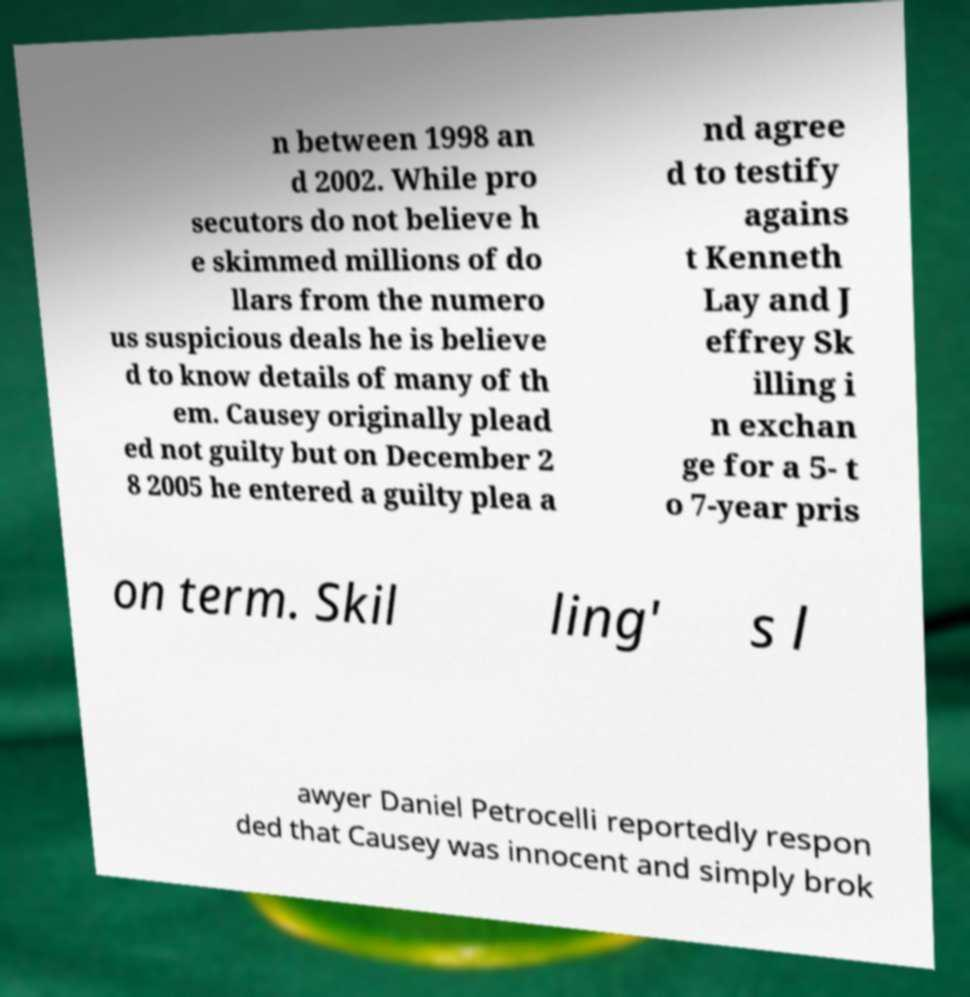For documentation purposes, I need the text within this image transcribed. Could you provide that? n between 1998 an d 2002. While pro secutors do not believe h e skimmed millions of do llars from the numero us suspicious deals he is believe d to know details of many of th em. Causey originally plead ed not guilty but on December 2 8 2005 he entered a guilty plea a nd agree d to testify agains t Kenneth Lay and J effrey Sk illing i n exchan ge for a 5- t o 7-year pris on term. Skil ling' s l awyer Daniel Petrocelli reportedly respon ded that Causey was innocent and simply brok 